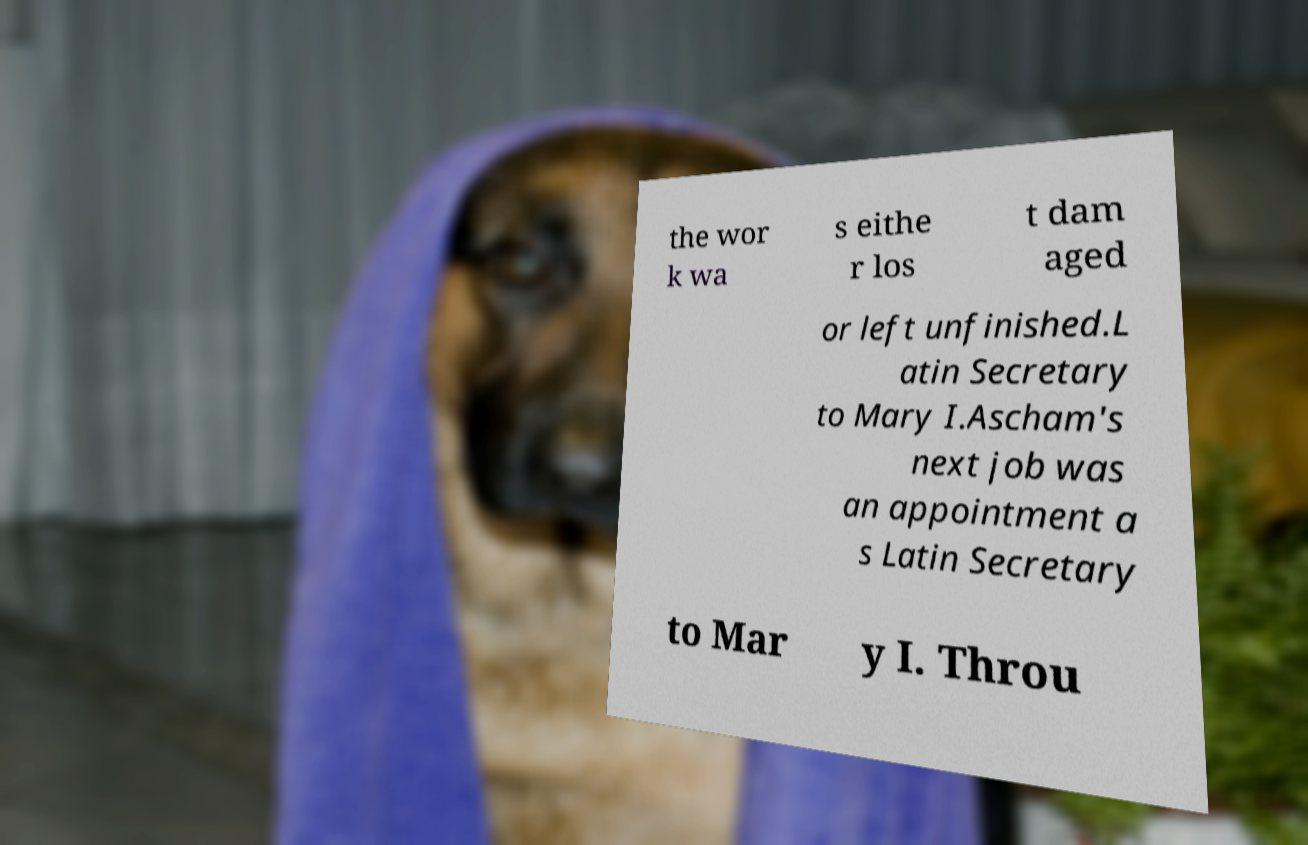For documentation purposes, I need the text within this image transcribed. Could you provide that? the wor k wa s eithe r los t dam aged or left unfinished.L atin Secretary to Mary I.Ascham's next job was an appointment a s Latin Secretary to Mar y I. Throu 